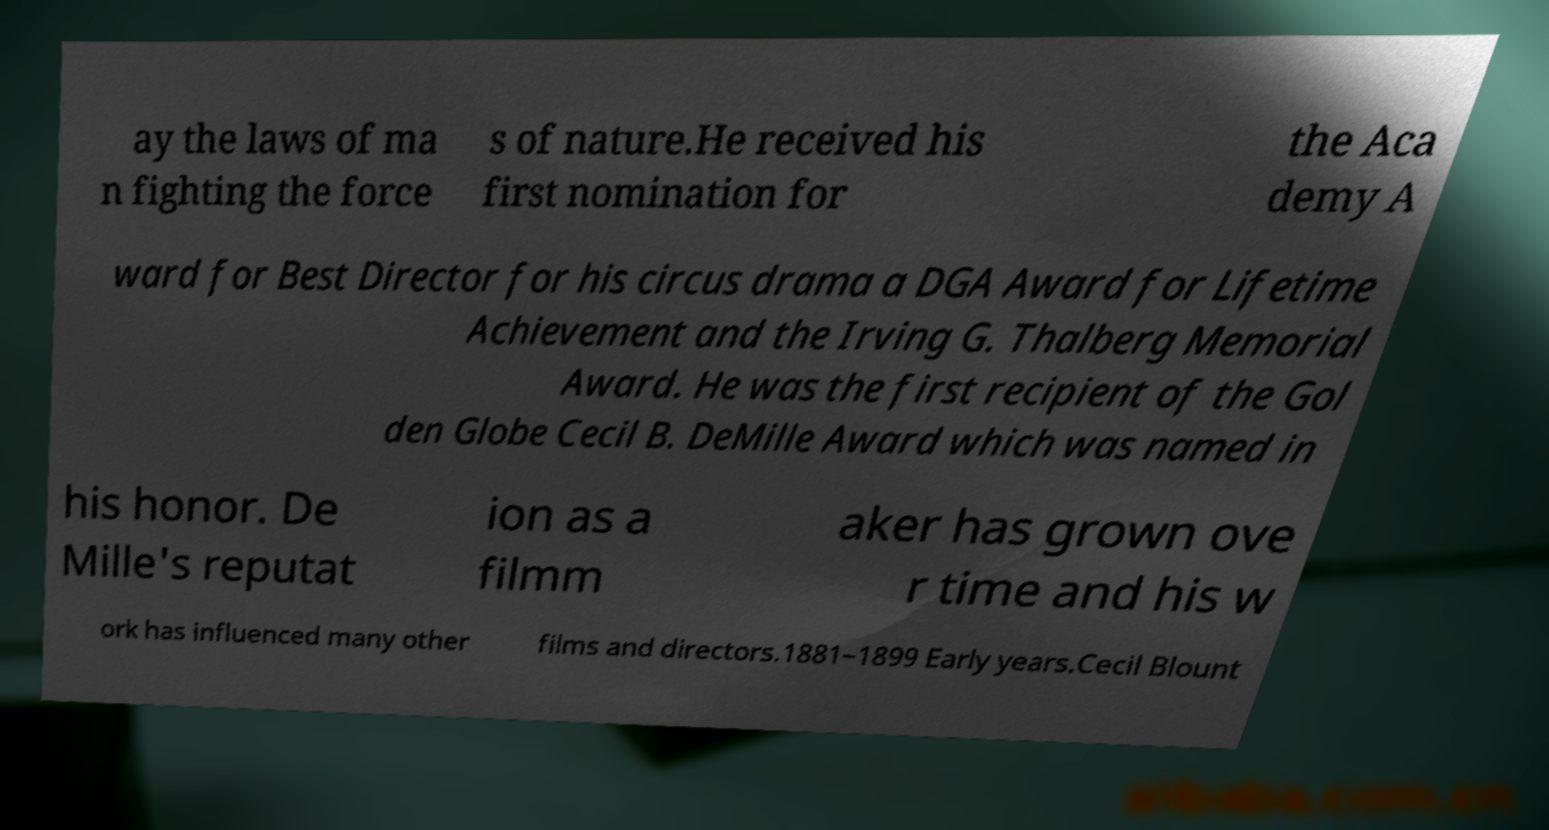Can you accurately transcribe the text from the provided image for me? ay the laws of ma n fighting the force s of nature.He received his first nomination for the Aca demy A ward for Best Director for his circus drama a DGA Award for Lifetime Achievement and the Irving G. Thalberg Memorial Award. He was the first recipient of the Gol den Globe Cecil B. DeMille Award which was named in his honor. De Mille's reputat ion as a filmm aker has grown ove r time and his w ork has influenced many other films and directors.1881–1899 Early years.Cecil Blount 